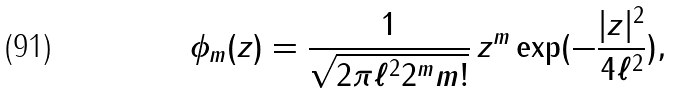Convert formula to latex. <formula><loc_0><loc_0><loc_500><loc_500>\phi _ { m } ( z ) = \frac { 1 } { \sqrt { 2 \pi \ell ^ { 2 } 2 ^ { m } m ! } } \, z ^ { m } \exp ( - \frac { | z | ^ { 2 } } { 4 \ell ^ { 2 } } ) ,</formula> 